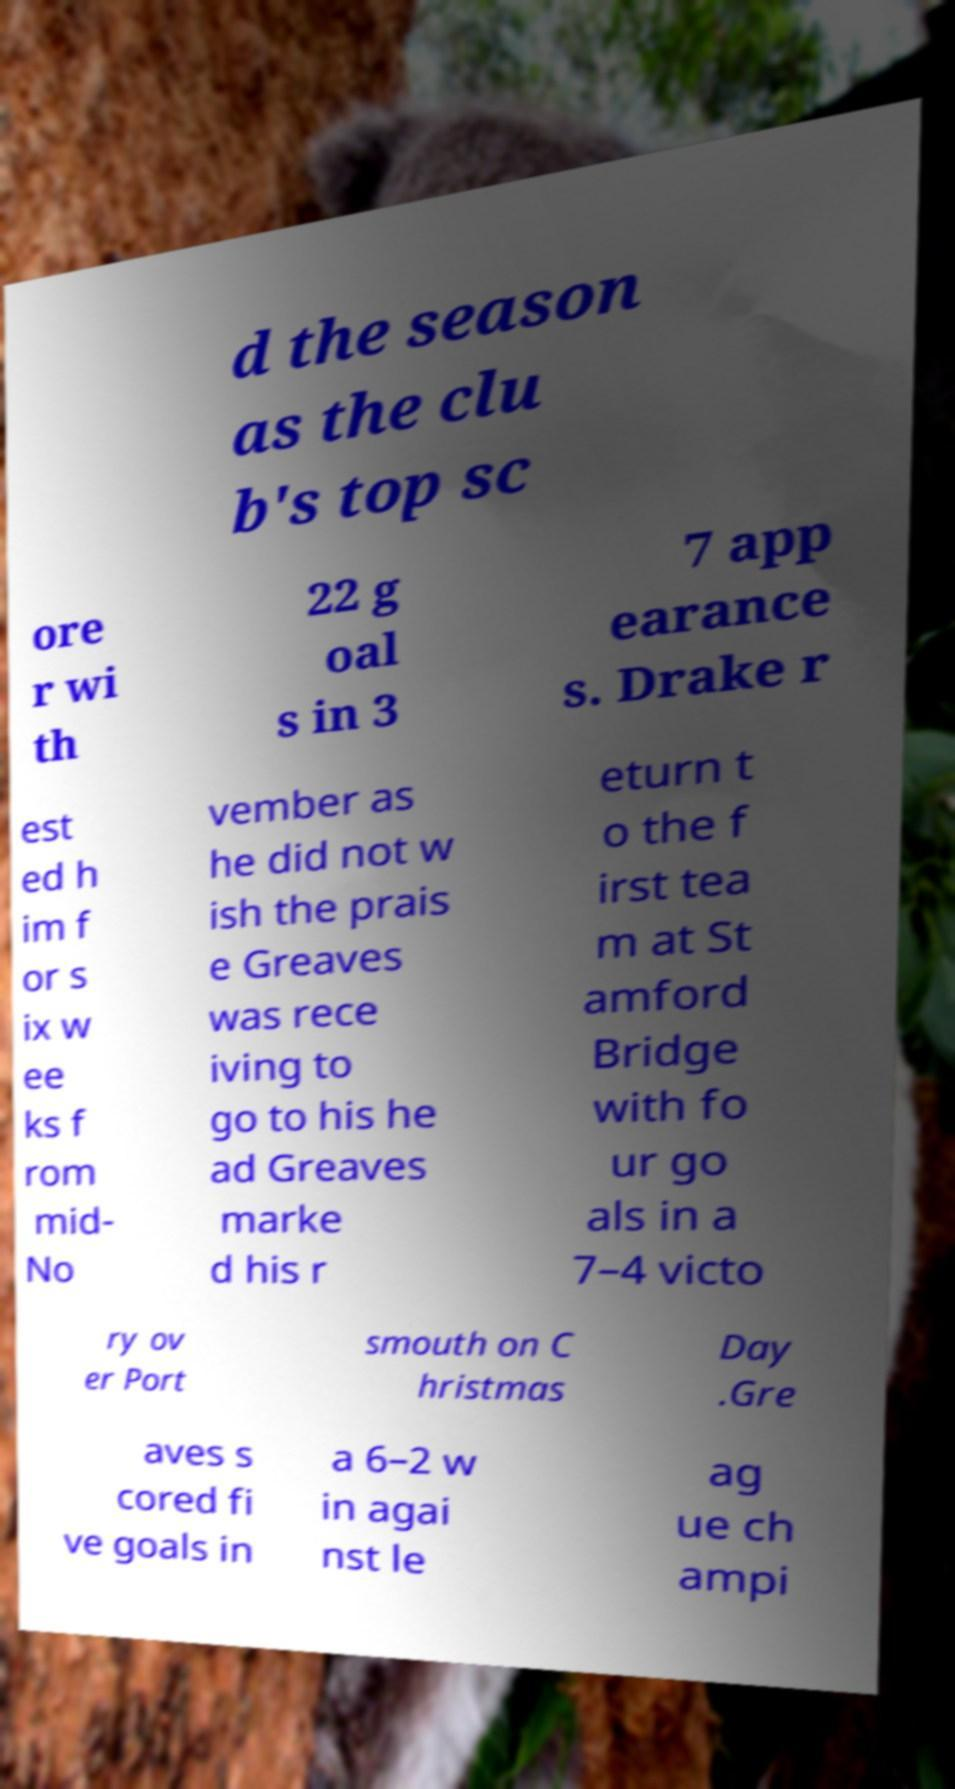Could you assist in decoding the text presented in this image and type it out clearly? d the season as the clu b's top sc ore r wi th 22 g oal s in 3 7 app earance s. Drake r est ed h im f or s ix w ee ks f rom mid- No vember as he did not w ish the prais e Greaves was rece iving to go to his he ad Greaves marke d his r eturn t o the f irst tea m at St amford Bridge with fo ur go als in a 7–4 victo ry ov er Port smouth on C hristmas Day .Gre aves s cored fi ve goals in a 6–2 w in agai nst le ag ue ch ampi 